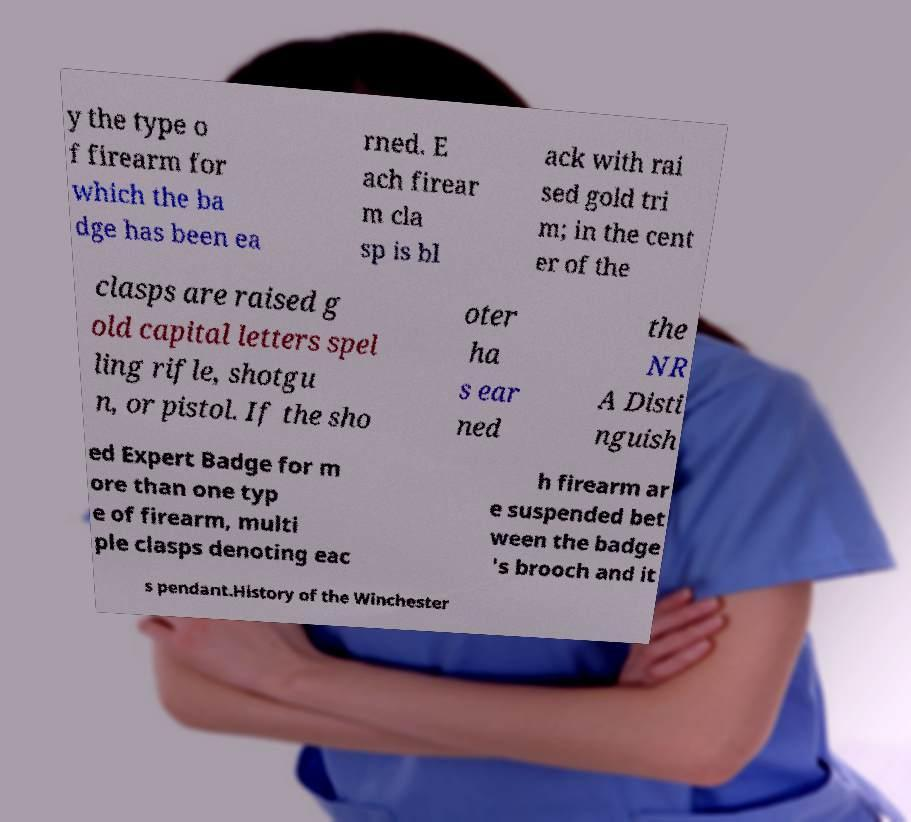What messages or text are displayed in this image? I need them in a readable, typed format. y the type o f firearm for which the ba dge has been ea rned. E ach firear m cla sp is bl ack with rai sed gold tri m; in the cent er of the clasps are raised g old capital letters spel ling rifle, shotgu n, or pistol. If the sho oter ha s ear ned the NR A Disti nguish ed Expert Badge for m ore than one typ e of firearm, multi ple clasps denoting eac h firearm ar e suspended bet ween the badge 's brooch and it s pendant.History of the Winchester 